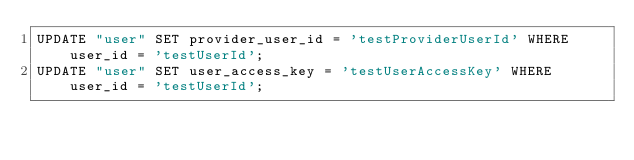<code> <loc_0><loc_0><loc_500><loc_500><_SQL_>UPDATE "user" SET provider_user_id = 'testProviderUserId' WHERE user_id = 'testUserId';
UPDATE "user" SET user_access_key = 'testUserAccessKey' WHERE user_id = 'testUserId';</code> 